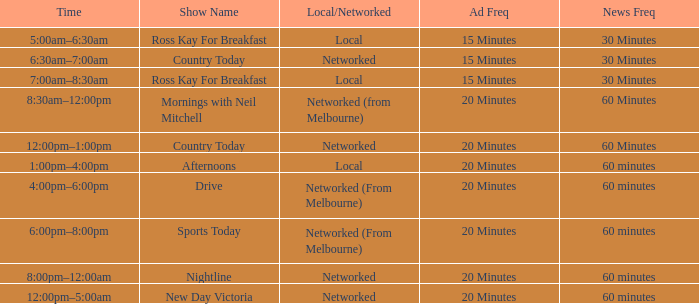When is the mornings with neil mitchell show scheduled to be on air? 8:30am–12:00pm. 